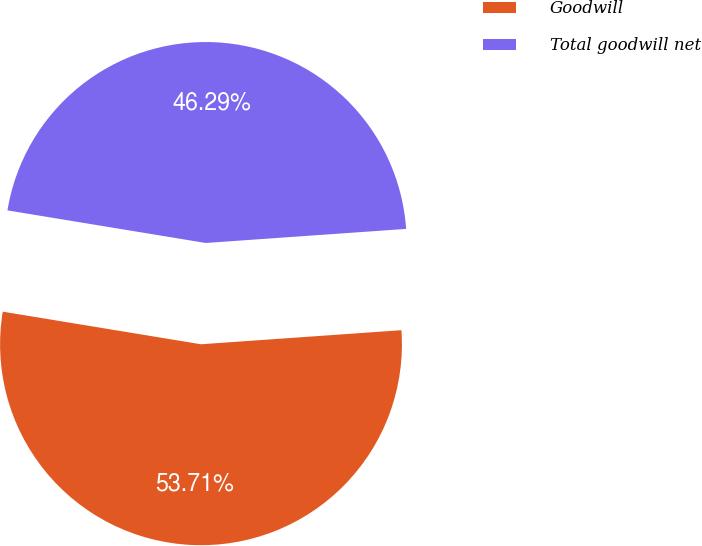<chart> <loc_0><loc_0><loc_500><loc_500><pie_chart><fcel>Goodwill<fcel>Total goodwill net<nl><fcel>53.71%<fcel>46.29%<nl></chart> 